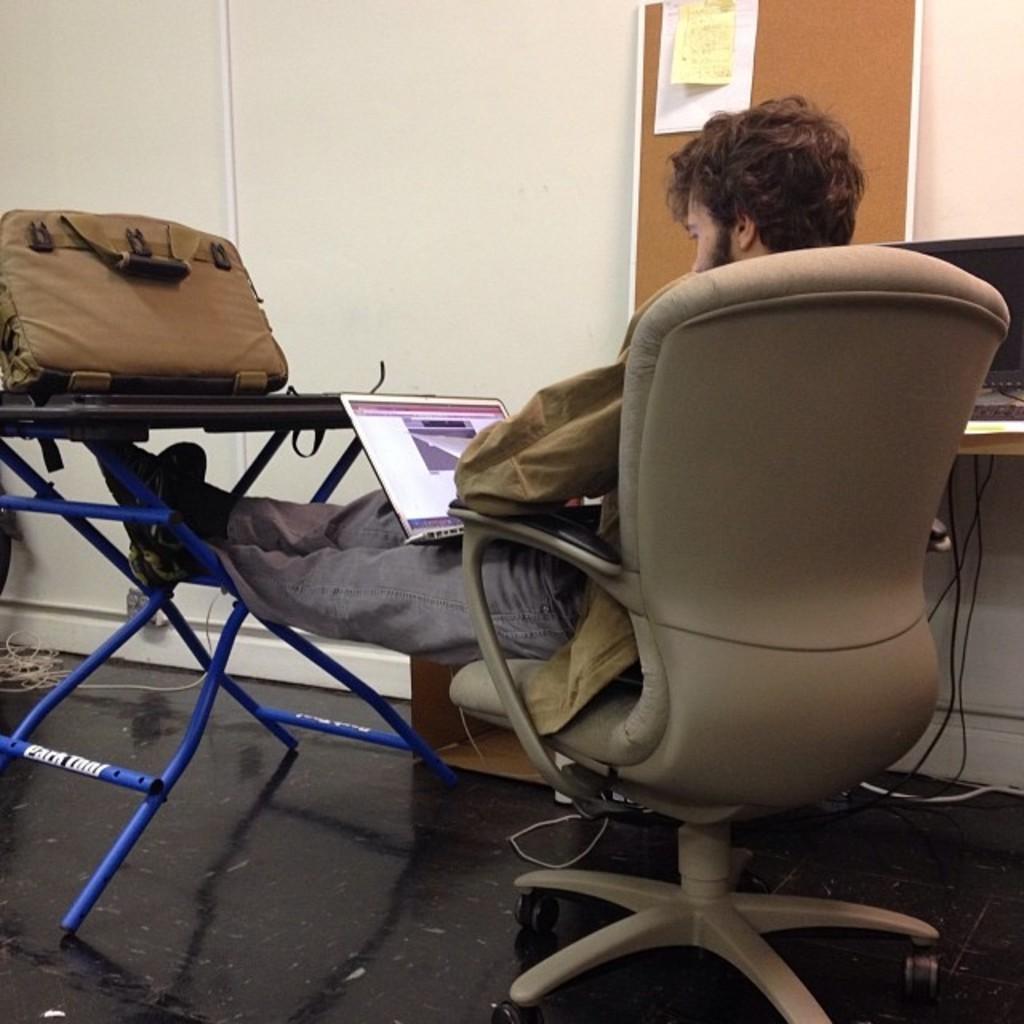Could you give a brief overview of what you see in this image? In the image we can see there is a person who is sitting on chair and on table there is luggage bag. There is a laptop which is on the lap of the person, there is a notice board on which there are papers which are attached to it. On the table there is another monitor and keyboard. The wall is in white colour. 